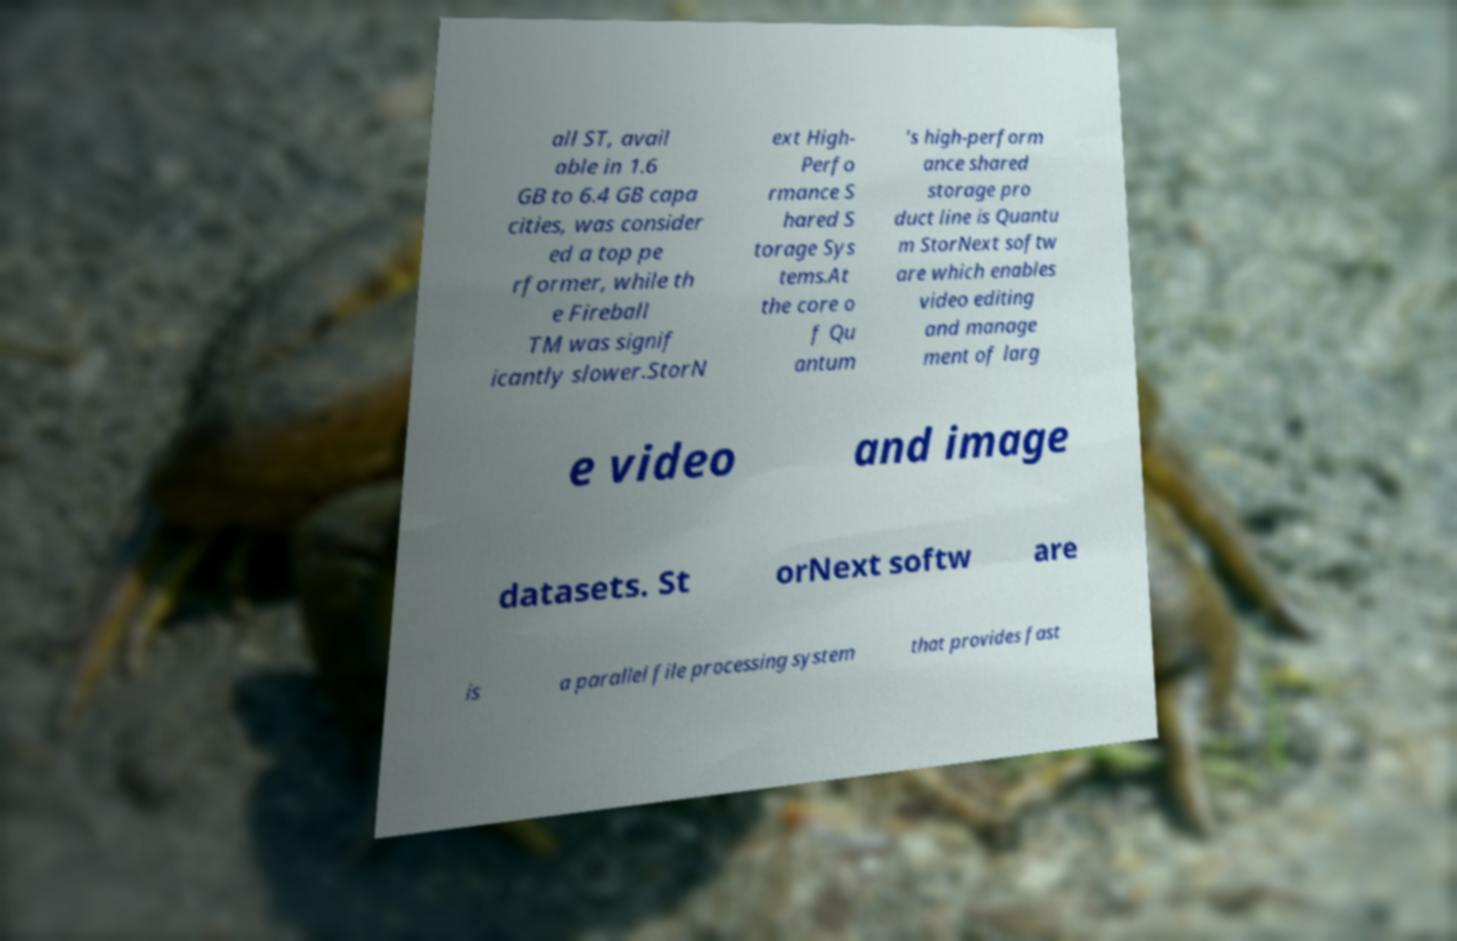For documentation purposes, I need the text within this image transcribed. Could you provide that? all ST, avail able in 1.6 GB to 6.4 GB capa cities, was consider ed a top pe rformer, while th e Fireball TM was signif icantly slower.StorN ext High- Perfo rmance S hared S torage Sys tems.At the core o f Qu antum ’s high-perform ance shared storage pro duct line is Quantu m StorNext softw are which enables video editing and manage ment of larg e video and image datasets. St orNext softw are is a parallel file processing system that provides fast 